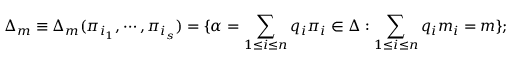<formula> <loc_0><loc_0><loc_500><loc_500>\Delta _ { m } \equiv \Delta _ { m } ( \pi _ { i _ { 1 } } , \cdots , \pi _ { i _ { s } } ) = \{ \alpha = \sum _ { 1 \leq i \leq n } q _ { i } \pi _ { i } \in \Delta \colon \sum _ { 1 \leq i \leq n } q _ { i } m _ { i } = m \} ;</formula> 